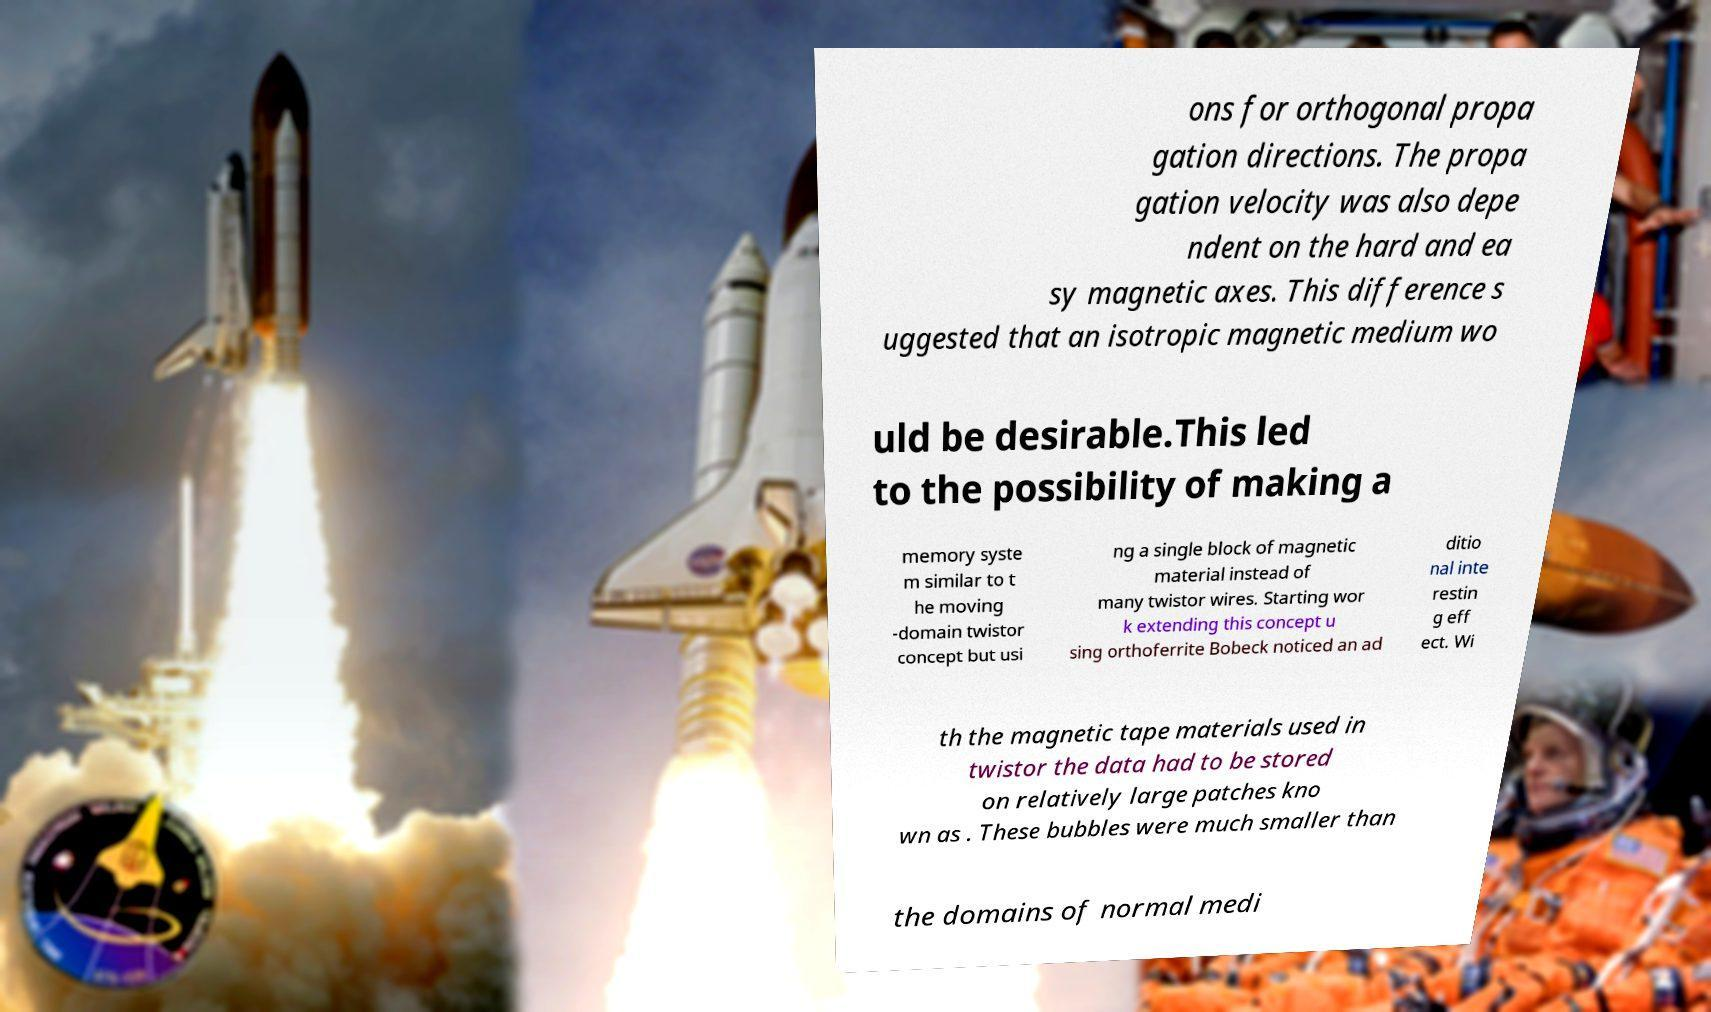For documentation purposes, I need the text within this image transcribed. Could you provide that? ons for orthogonal propa gation directions. The propa gation velocity was also depe ndent on the hard and ea sy magnetic axes. This difference s uggested that an isotropic magnetic medium wo uld be desirable.This led to the possibility of making a memory syste m similar to t he moving -domain twistor concept but usi ng a single block of magnetic material instead of many twistor wires. Starting wor k extending this concept u sing orthoferrite Bobeck noticed an ad ditio nal inte restin g eff ect. Wi th the magnetic tape materials used in twistor the data had to be stored on relatively large patches kno wn as . These bubbles were much smaller than the domains of normal medi 